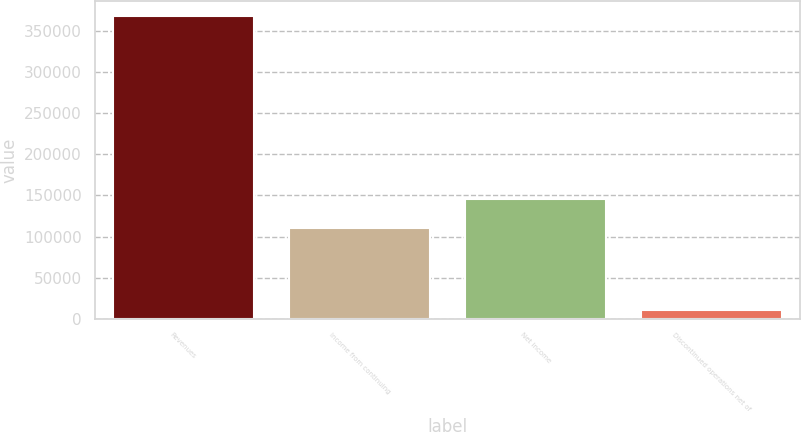Convert chart to OTSL. <chart><loc_0><loc_0><loc_500><loc_500><bar_chart><fcel>Revenues<fcel>Income from continuing<fcel>Net income<fcel>Discontinued operations net of<nl><fcel>368212<fcel>109968<fcel>145766<fcel>10234<nl></chart> 